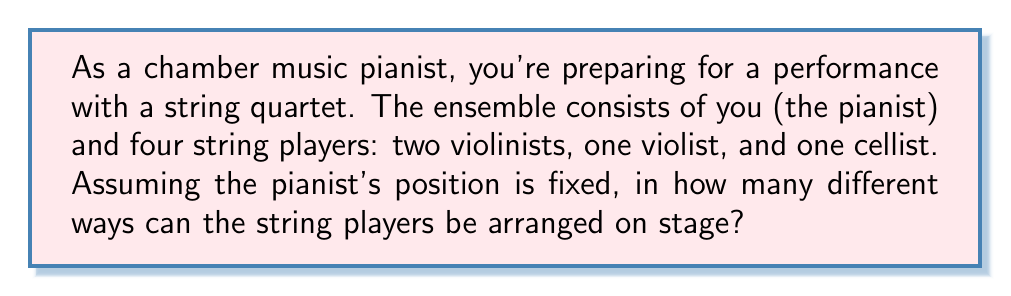Can you answer this question? Let's approach this step-by-step:

1) First, we need to recognize that this is a permutation problem. We are arranging all 4 string players in different orders.

2) However, it's not a straightforward permutation of 4 elements because there are two violinists who play the same instrument. Swapping these two violinists doesn't create a new arrangement from the audience's perspective.

3) This scenario is best handled by using the permutation formula and then dividing by the number of ways to arrange the identical elements (in this case, the two violinists).

4) The formula for permutations of n distinct objects is:

   $$P(n) = n!$$

5) In our case, if all players were distinct, we would have 4! arrangements.

6) However, since there are 2 violinists who are interchangeable, we need to divide by 2! to account for their arrangements that don't create a new overall arrangement.

7) Therefore, the number of distinct arrangements is:

   $$\frac{4!}{2!} = \frac{24}{2} = 12$$

Thus, there are 12 different ways to arrange the string players on stage.
Answer: 12 